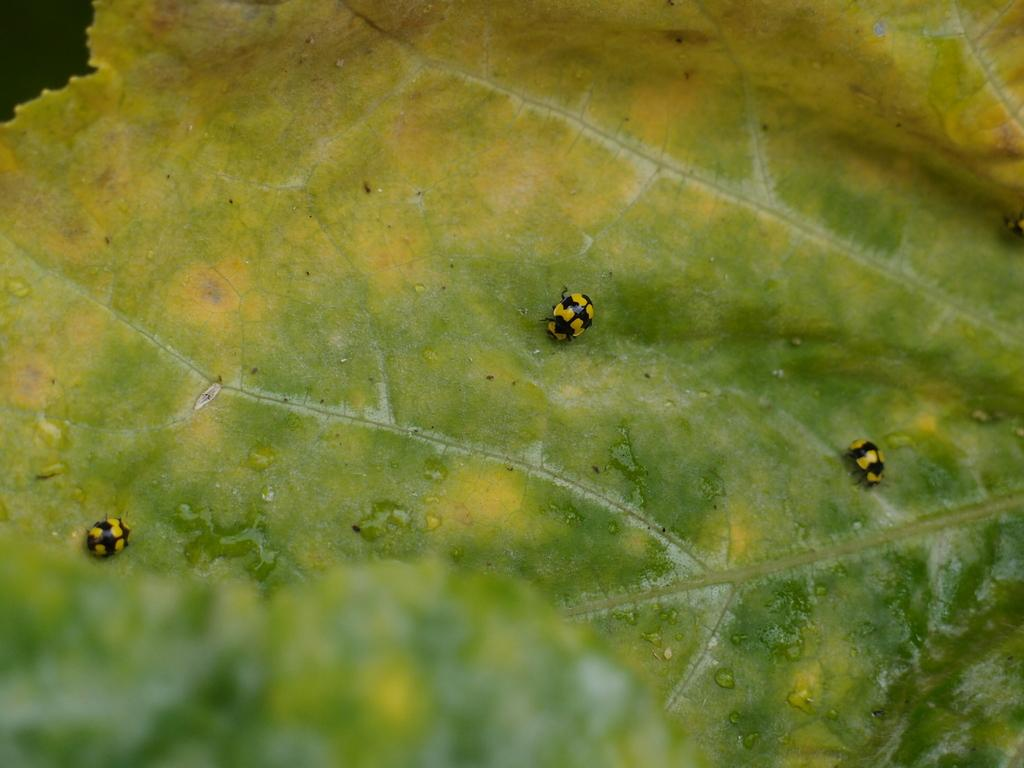What is present on the leaf in the image? There are insects on a leaf in the image. Can you describe the insects in the image? Unfortunately, the image does not provide enough detail to describe the insects. How much money is being exchanged between the insects in the image? There is no money present in the image, as it features insects on a leaf. Is there a trail visible in the image? There is no trail present in the image, as it features insects on a leaf. 